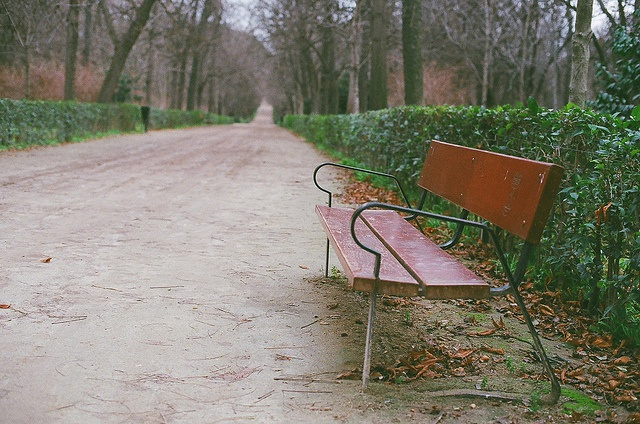Describe the objects in this image and their specific colors. I can see a bench in black, olive, maroon, and darkgray tones in this image. 